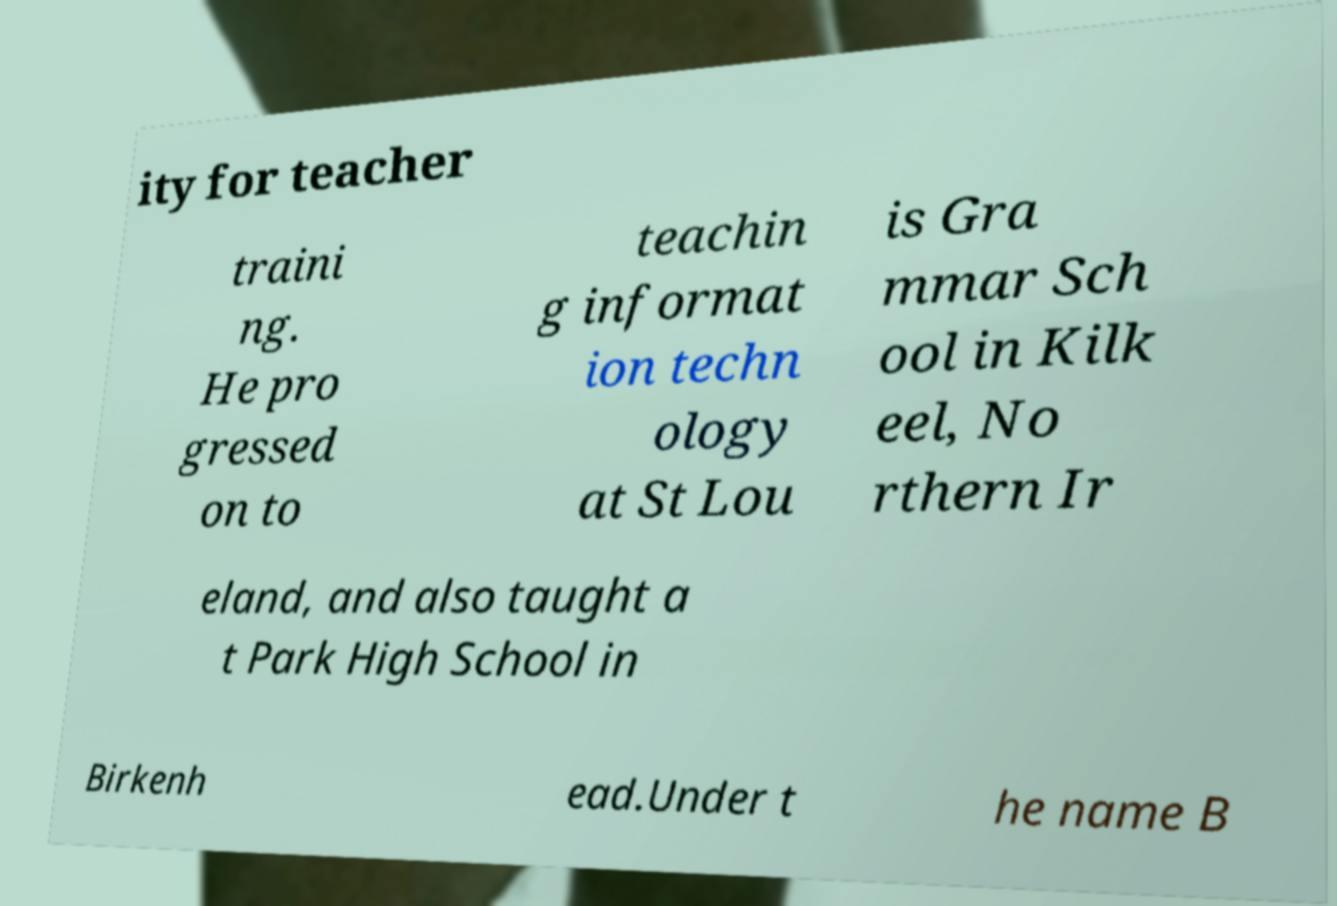There's text embedded in this image that I need extracted. Can you transcribe it verbatim? ity for teacher traini ng. He pro gressed on to teachin g informat ion techn ology at St Lou is Gra mmar Sch ool in Kilk eel, No rthern Ir eland, and also taught a t Park High School in Birkenh ead.Under t he name B 